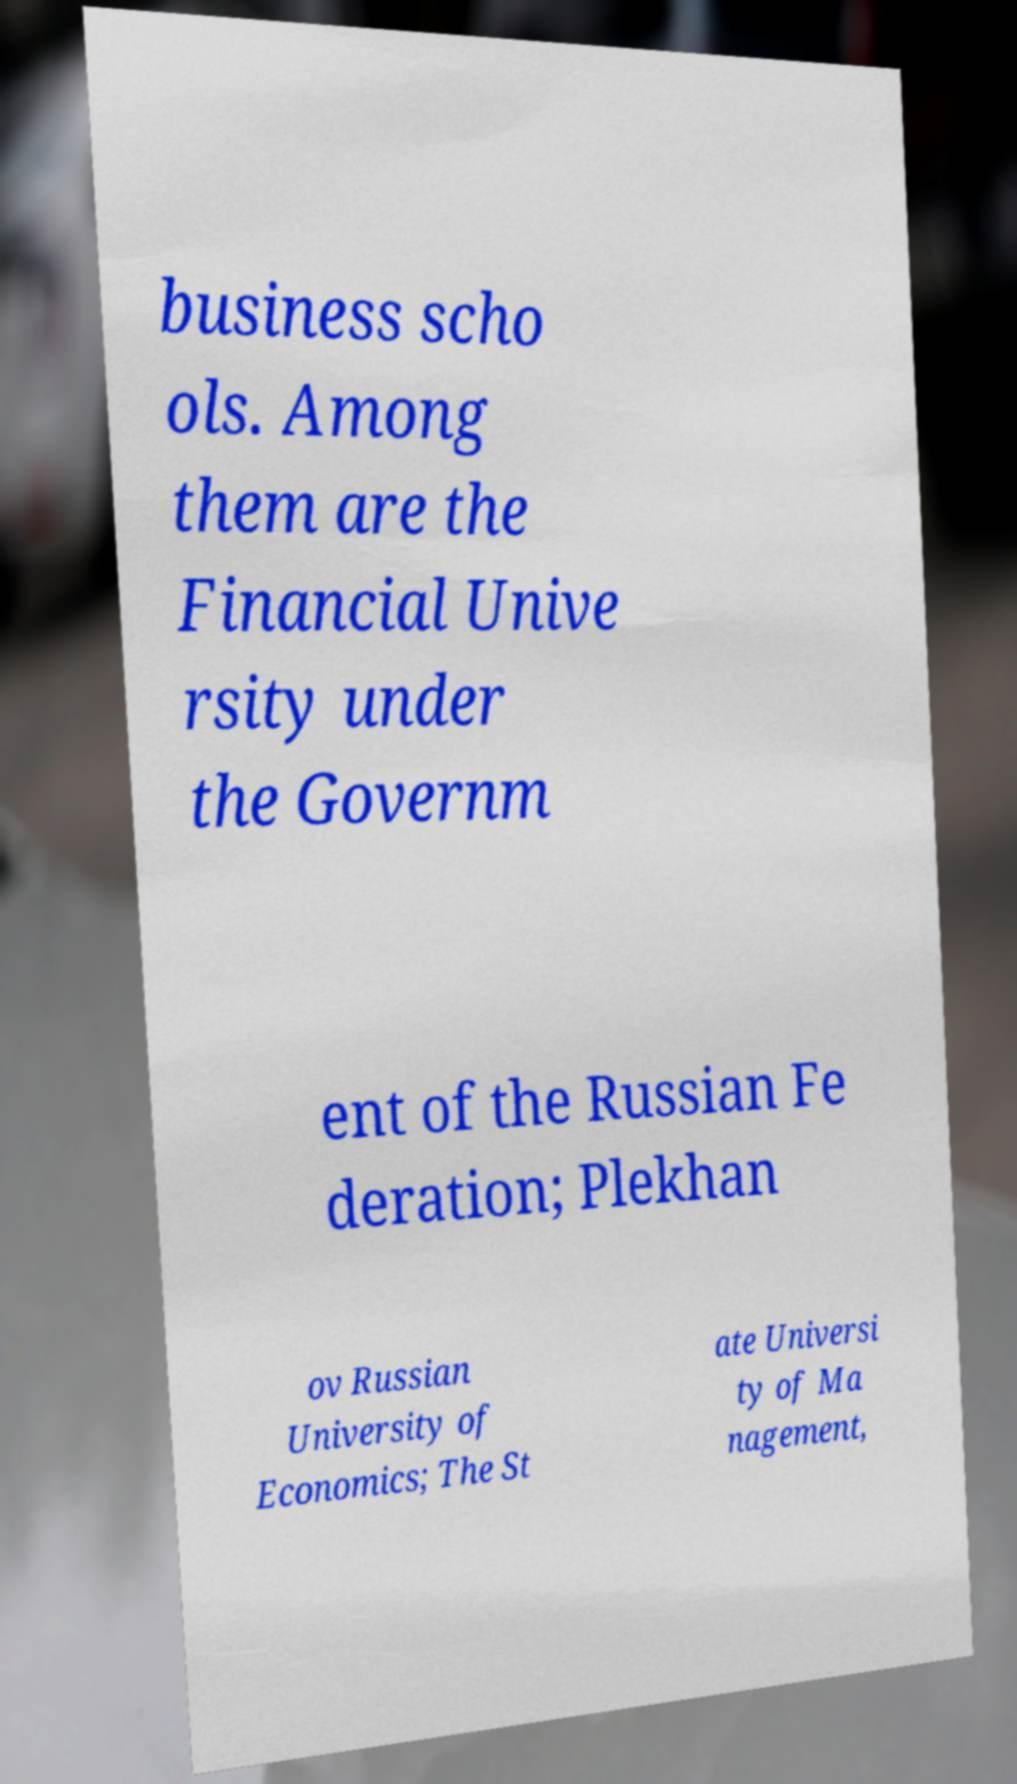For documentation purposes, I need the text within this image transcribed. Could you provide that? business scho ols. Among them are the Financial Unive rsity under the Governm ent of the Russian Fe deration; Plekhan ov Russian University of Economics; The St ate Universi ty of Ma nagement, 